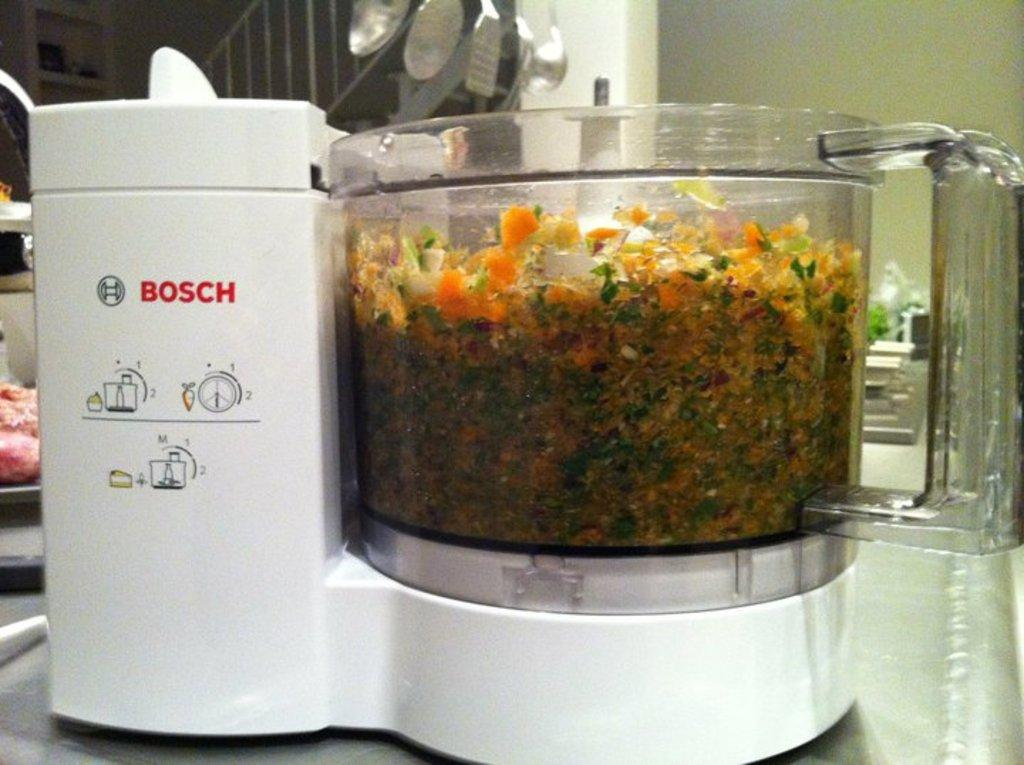<image>
Write a terse but informative summary of the picture. white bosch food processor that is full of chopped multicolor food 